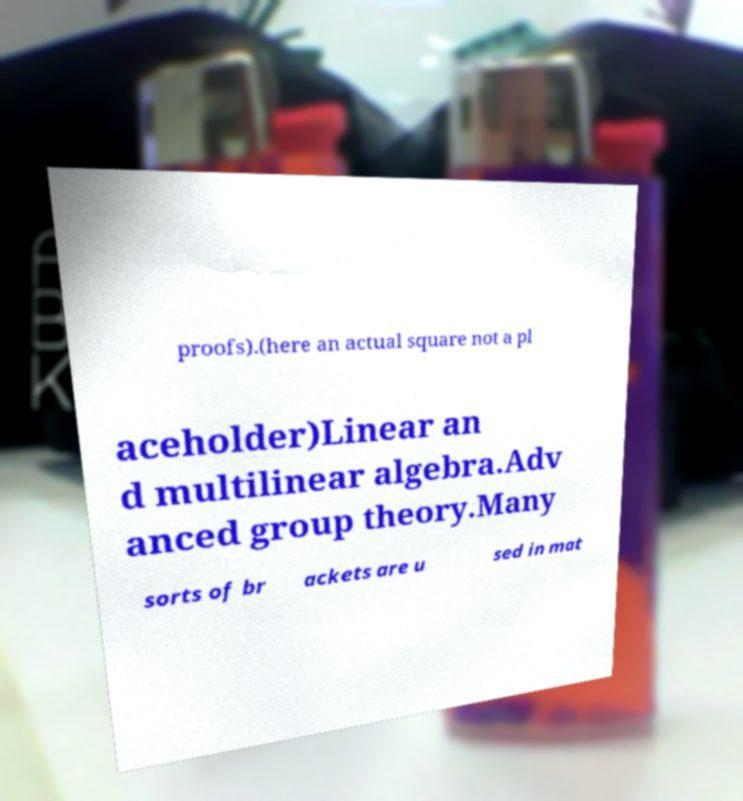Could you extract and type out the text from this image? proofs).(here an actual square not a pl aceholder)Linear an d multilinear algebra.Adv anced group theory.Many sorts of br ackets are u sed in mat 